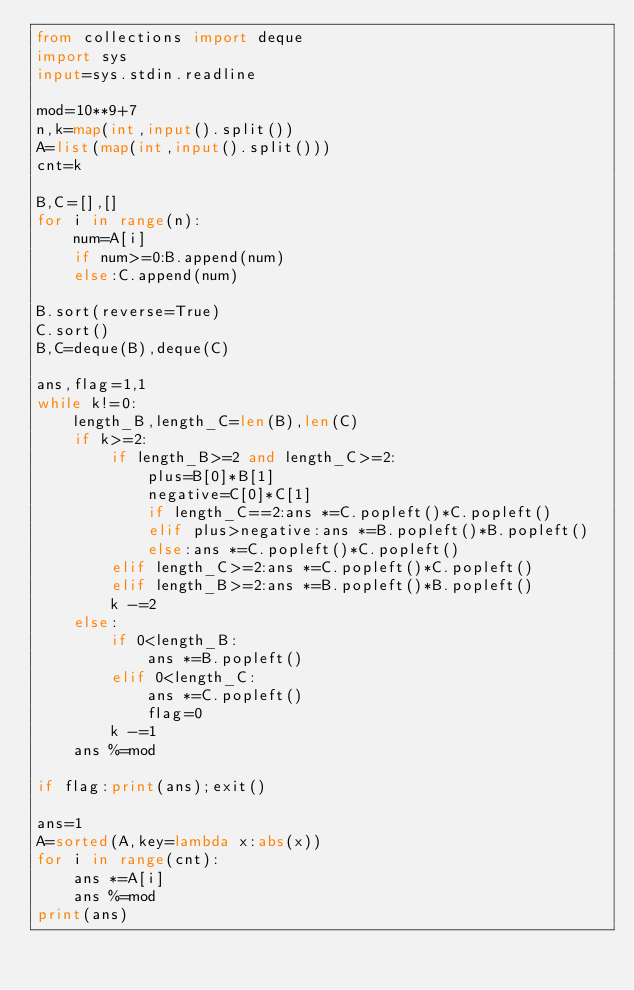Convert code to text. <code><loc_0><loc_0><loc_500><loc_500><_Python_>from collections import deque
import sys
input=sys.stdin.readline

mod=10**9+7
n,k=map(int,input().split())
A=list(map(int,input().split()))
cnt=k

B,C=[],[]
for i in range(n):
    num=A[i]
    if num>=0:B.append(num)
    else:C.append(num)

B.sort(reverse=True)
C.sort()
B,C=deque(B),deque(C)

ans,flag=1,1
while k!=0:
    length_B,length_C=len(B),len(C)
    if k>=2:
        if length_B>=2 and length_C>=2:
            plus=B[0]*B[1]
            negative=C[0]*C[1]
            if length_C==2:ans *=C.popleft()*C.popleft()
            elif plus>negative:ans *=B.popleft()*B.popleft()
            else:ans *=C.popleft()*C.popleft()
        elif length_C>=2:ans *=C.popleft()*C.popleft()
        elif length_B>=2:ans *=B.popleft()*B.popleft()
        k -=2
    else:
        if 0<length_B:
            ans *=B.popleft()
        elif 0<length_C:
            ans *=C.popleft()
            flag=0
        k -=1
    ans %=mod

if flag:print(ans);exit()

ans=1
A=sorted(A,key=lambda x:abs(x))
for i in range(cnt):
    ans *=A[i]
    ans %=mod
print(ans)</code> 